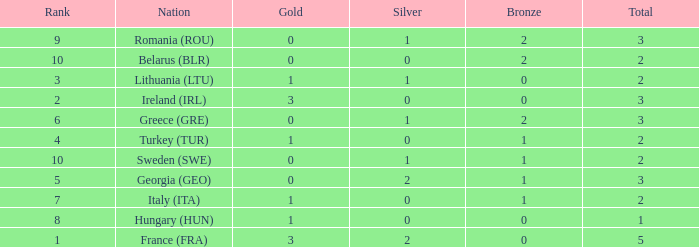Would you be able to parse every entry in this table? {'header': ['Rank', 'Nation', 'Gold', 'Silver', 'Bronze', 'Total'], 'rows': [['9', 'Romania (ROU)', '0', '1', '2', '3'], ['10', 'Belarus (BLR)', '0', '0', '2', '2'], ['3', 'Lithuania (LTU)', '1', '1', '0', '2'], ['2', 'Ireland (IRL)', '3', '0', '0', '3'], ['6', 'Greece (GRE)', '0', '1', '2', '3'], ['4', 'Turkey (TUR)', '1', '0', '1', '2'], ['10', 'Sweden (SWE)', '0', '1', '1', '2'], ['5', 'Georgia (GEO)', '0', '2', '1', '3'], ['7', 'Italy (ITA)', '1', '0', '1', '2'], ['8', 'Hungary (HUN)', '1', '0', '0', '1'], ['1', 'France (FRA)', '3', '2', '0', '5']]} What's the rank of Turkey (TUR) with a total more than 2? 0.0. 